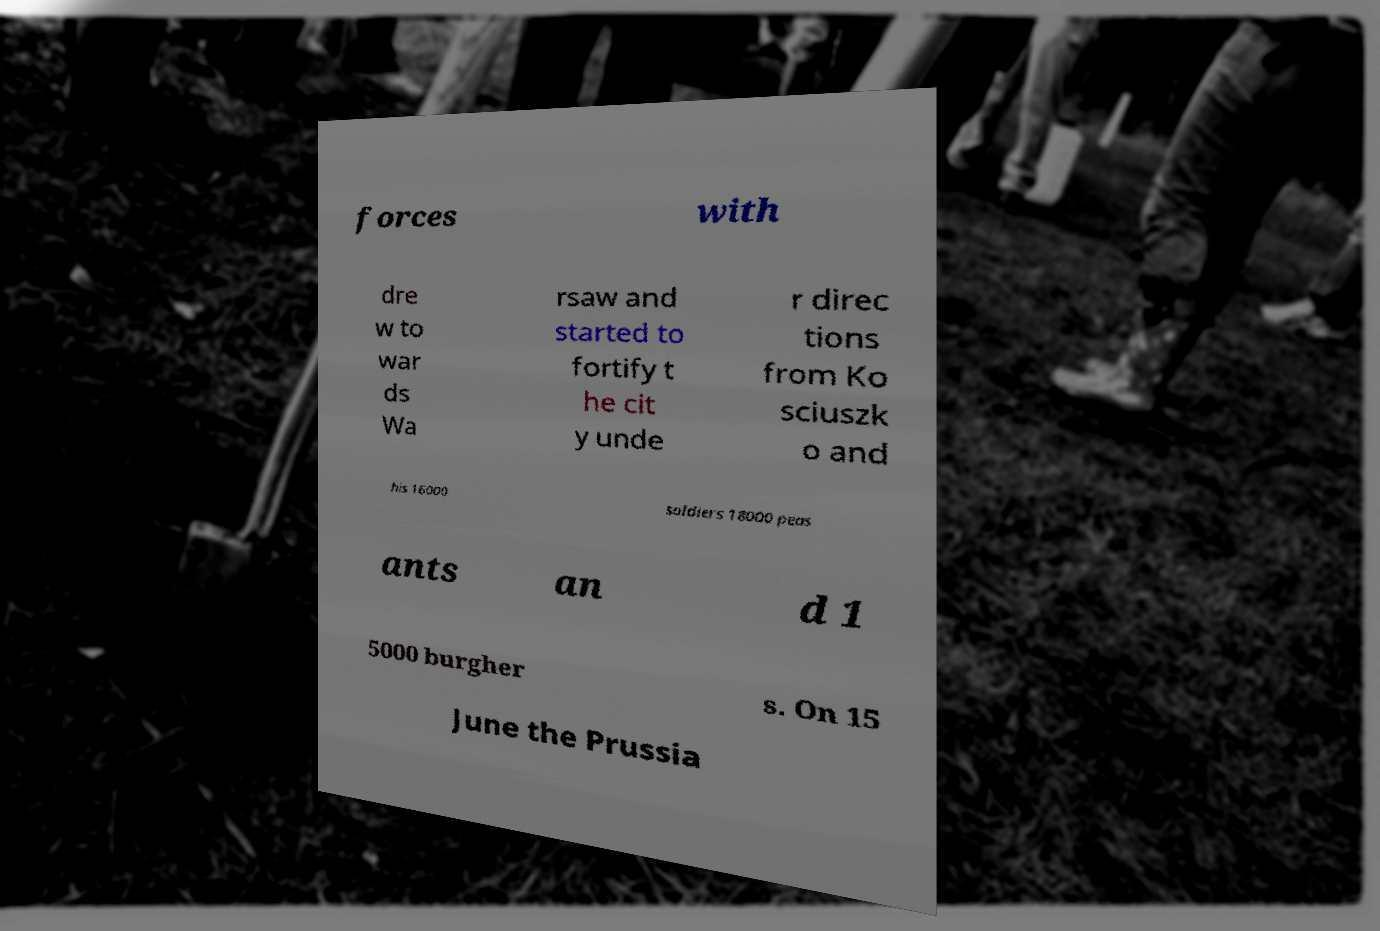Please identify and transcribe the text found in this image. forces with dre w to war ds Wa rsaw and started to fortify t he cit y unde r direc tions from Ko sciuszk o and his 16000 soldiers 18000 peas ants an d 1 5000 burgher s. On 15 June the Prussia 